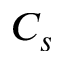<formula> <loc_0><loc_0><loc_500><loc_500>C _ { s }</formula> 